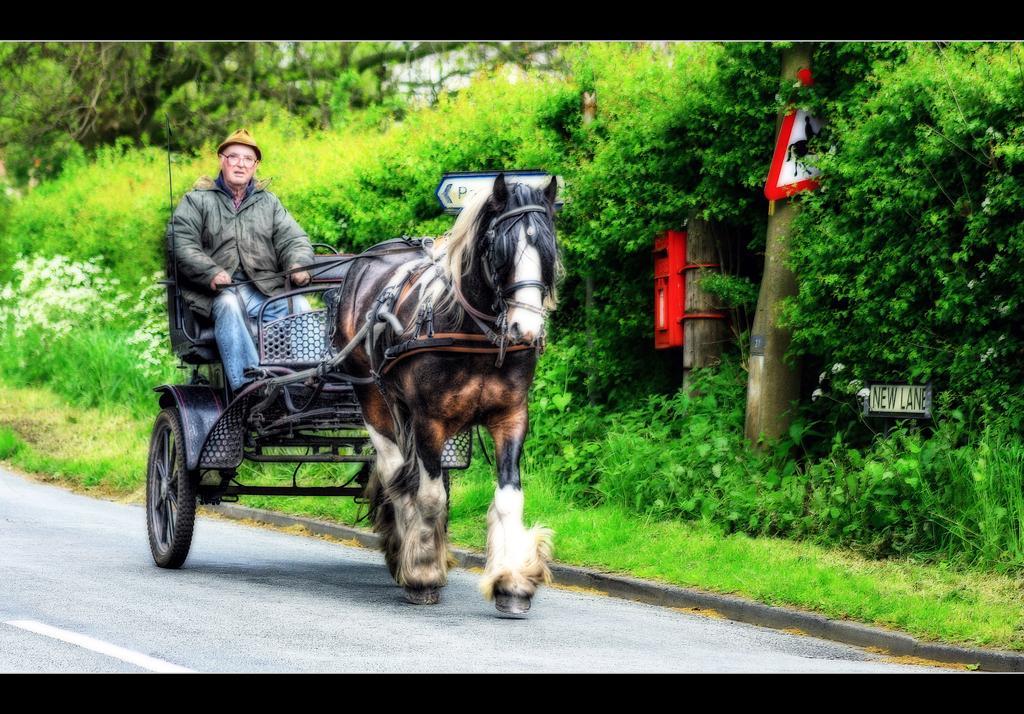Could you give a brief overview of what you see in this image? In this image a man sitting is sitting in the seat fixed to the horse which is walking on the road and at the back ground there is a sign board fixed to the tree , garden, grass , plants ,flowers, plants ,trees. 